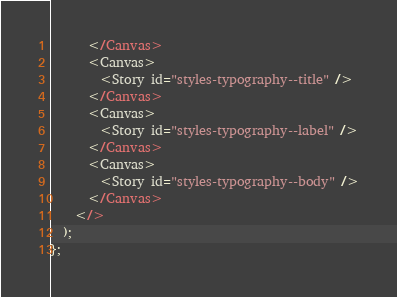<code> <loc_0><loc_0><loc_500><loc_500><_TypeScript_>      </Canvas>
      <Canvas>
        <Story id="styles-typography--title" />
      </Canvas>
      <Canvas>
        <Story id="styles-typography--label" />
      </Canvas>
      <Canvas>
        <Story id="styles-typography--body" />
      </Canvas>
    </>
  );
};
</code> 